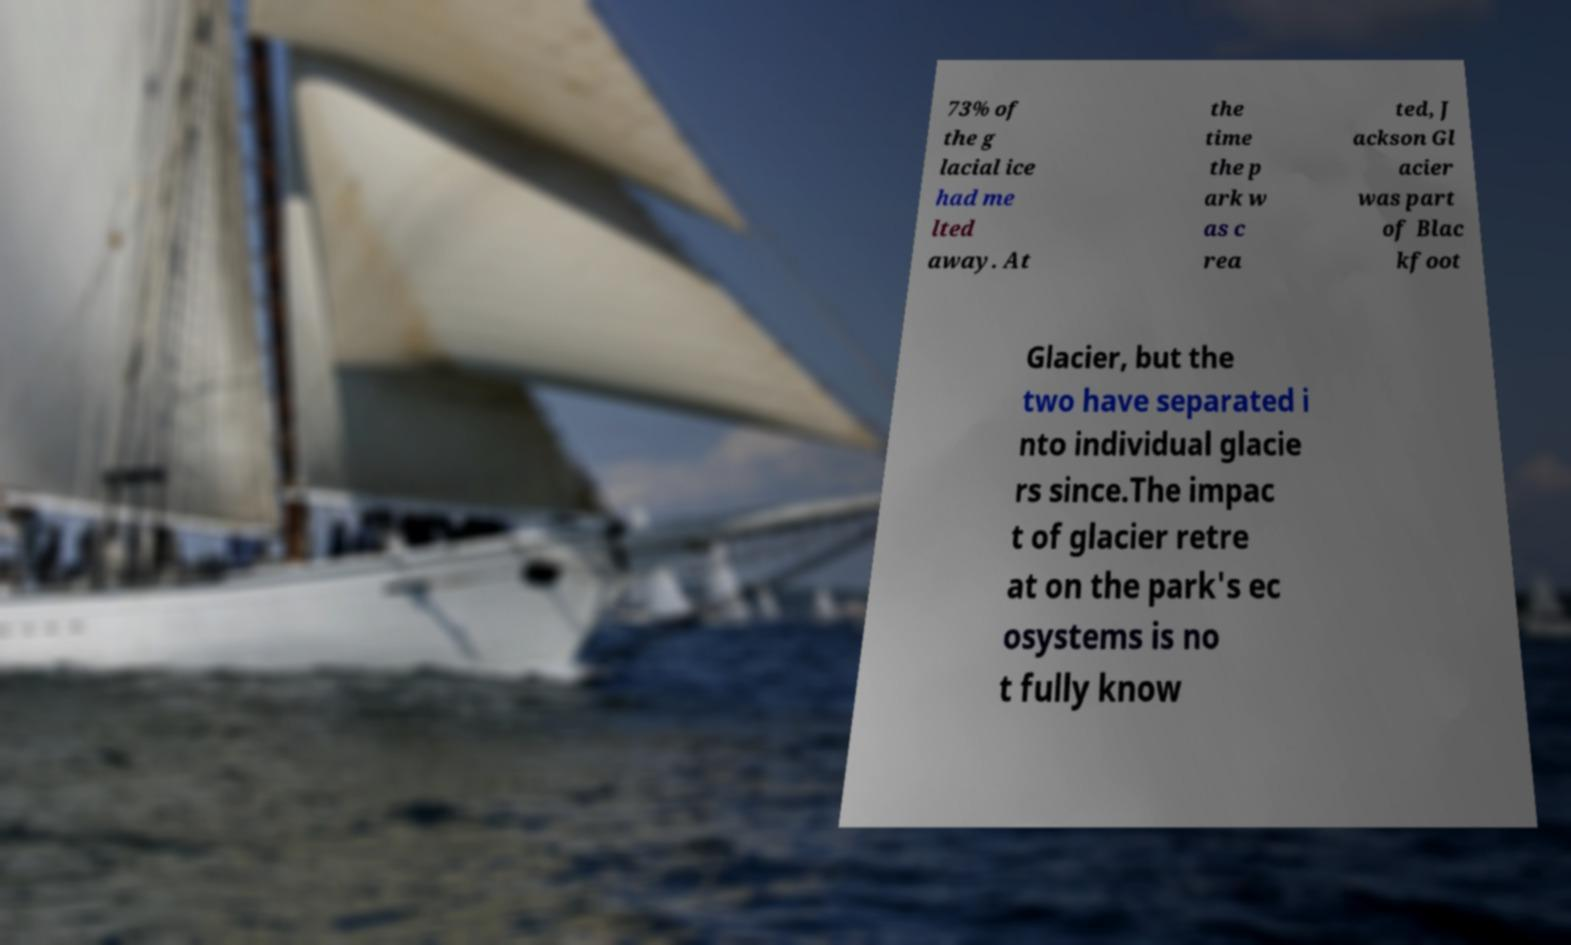There's text embedded in this image that I need extracted. Can you transcribe it verbatim? 73% of the g lacial ice had me lted away. At the time the p ark w as c rea ted, J ackson Gl acier was part of Blac kfoot Glacier, but the two have separated i nto individual glacie rs since.The impac t of glacier retre at on the park's ec osystems is no t fully know 